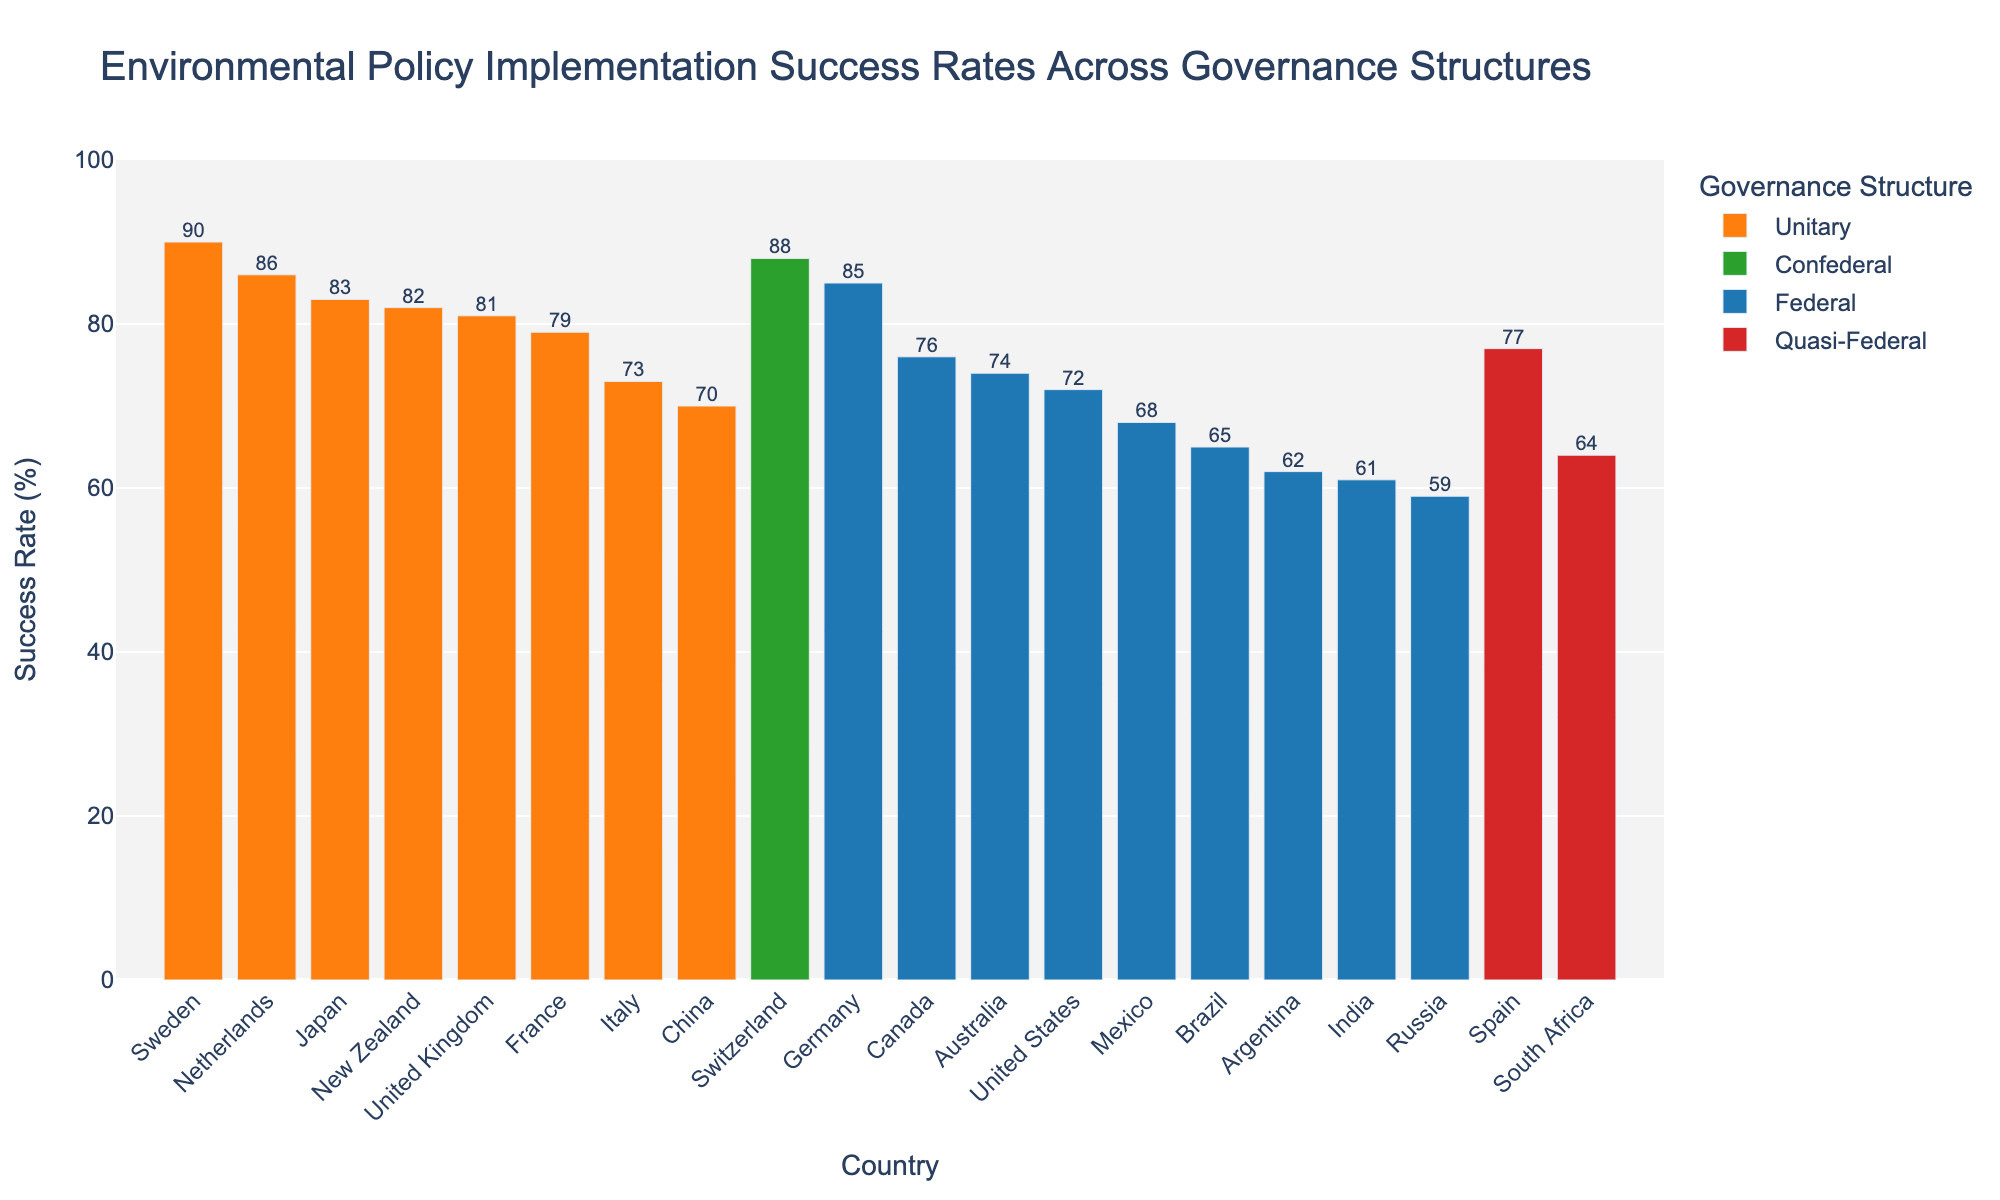What's the highest success rate among the countries? The highest bar in the chart represents the country with the highest success rate. From the visual information, Switzerland has the tallest bar with a success rate of 88%.
Answer: 88% Which governance structure has the highest average policy implementation success rate? Calculate the average success rate for each governance structure by summing the success rates of countries under that structure and dividing by the number of countries. Unitary: (79+81+83+70+73+86+82+90)/8 = 80.5, Federal: (72+85+76+74+65+61+68+59+62)/9 = 69.1, Confederal: 88/1 = 88, Quasi-Federal: (77+64)/2 = 70.5. The Confederal structure has the highest average success rate.
Answer: Confederal Which country under the federal governance structure has the lowest success rate? Look at the bars colored for the federal governance structure and identify the country with the shortest bar. Russia has the lowest success rate among federal countries with 59%.
Answer: Russia What is the total implementation success rate for countries with a unitary governance structure? Sum the success rates of all countries labeled as Unitary. France (79) + The UK (81) + Japan (83) + China (70) + Italy (73) + The Netherlands (86) + New Zealand (82) + Sweden (90) = 644.
Answer: 644 How does the success rate for Canada compare to that of Japan? Compare the heights of the bars for Canada (Federal) and Japan (Unitary). Canada's success rate is 76% while Japan's is 83%. Japan has a higher success rate.
Answer: Japan has a higher success rate What is the difference in implementation success rates between the highest and the lowest performing countries? Identify the highest (Switzerland, 88%) and the lowest (Russia, 59%) success rates from the chart and subtract the latter from the former. 88 - 59 = 29.
Answer: 29 Are there any countries with a success rate between 70% and 75%? If so, which? Look for the bars where the success rates fall into the 70%-75% range. Canada (Federal, 76%) just misses it, but China (Unitary, 70%) and Italy (Unitary, 73%) fall within this range.
Answer: China, Italy Which country has the closest success rate to that of Spain? Compare the bars to Spain's success rate of 77%. Look for the country with a success rate closest to 77%. Canada and Spain both have the same success rate of 77%.
Answer: Canada Considering federal governance structures, which country has the second-highest success rate? Order the countries with federal governance structures by their success rates and identify the second-highest. Germany (85) has the highest, followed by the United States (72).
Answer: United States What is the median success rate among all countries? To find the median, list all success rates in ascending order and find the middle value. Ordered: 59, 61, 62, 64, 65, 68, 70, 72, 73, 74, 76, 77, 79, 81, 82, 83, 85, 86, 88. The median (middle value of this 19-element list) is 74 (Australia's success rate).
Answer: 74 